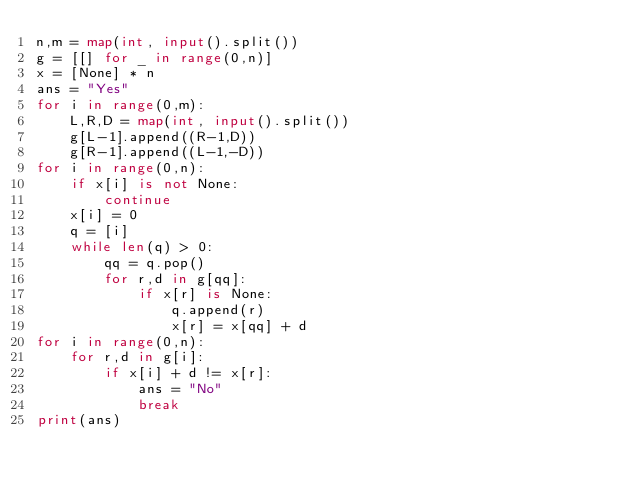Convert code to text. <code><loc_0><loc_0><loc_500><loc_500><_Python_>n,m = map(int, input().split())
g = [[] for _ in range(0,n)]
x = [None] * n
ans = "Yes"
for i in range(0,m):
    L,R,D = map(int, input().split())
    g[L-1].append((R-1,D))
    g[R-1].append((L-1,-D))
for i in range(0,n):
    if x[i] is not None:
        continue
    x[i] = 0
    q = [i]
    while len(q) > 0:
        qq = q.pop()
        for r,d in g[qq]:
            if x[r] is None:
                q.append(r)
                x[r] = x[qq] + d
for i in range(0,n):
    for r,d in g[i]:
        if x[i] + d != x[r]:
            ans = "No"
            break
print(ans)
</code> 